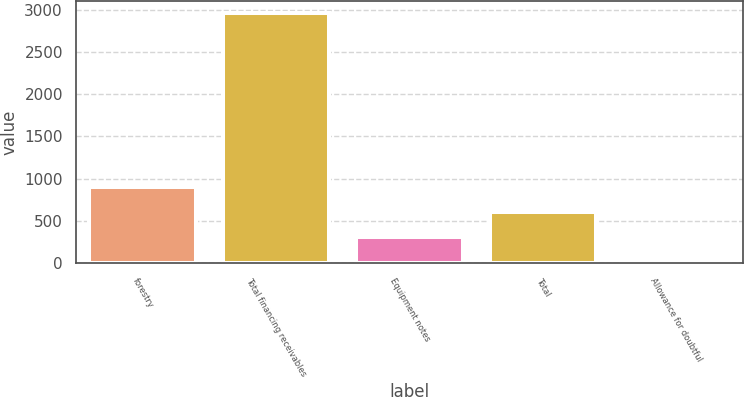<chart> <loc_0><loc_0><loc_500><loc_500><bar_chart><fcel>forestry<fcel>Total financing receivables<fcel>Equipment notes<fcel>Total<fcel>Allowance for doubtful<nl><fcel>900.3<fcel>2959<fcel>312.1<fcel>606.2<fcel>18<nl></chart> 